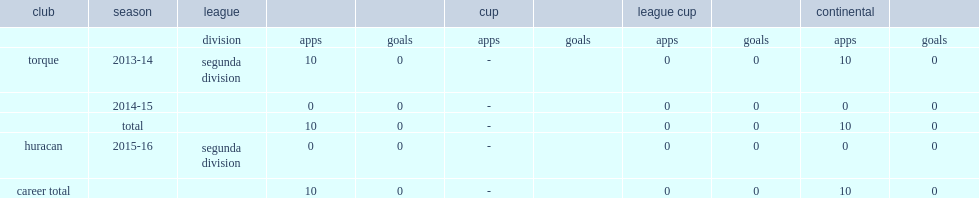Which club did luis manuel lopez vier play for in 2013-14? Torque. 